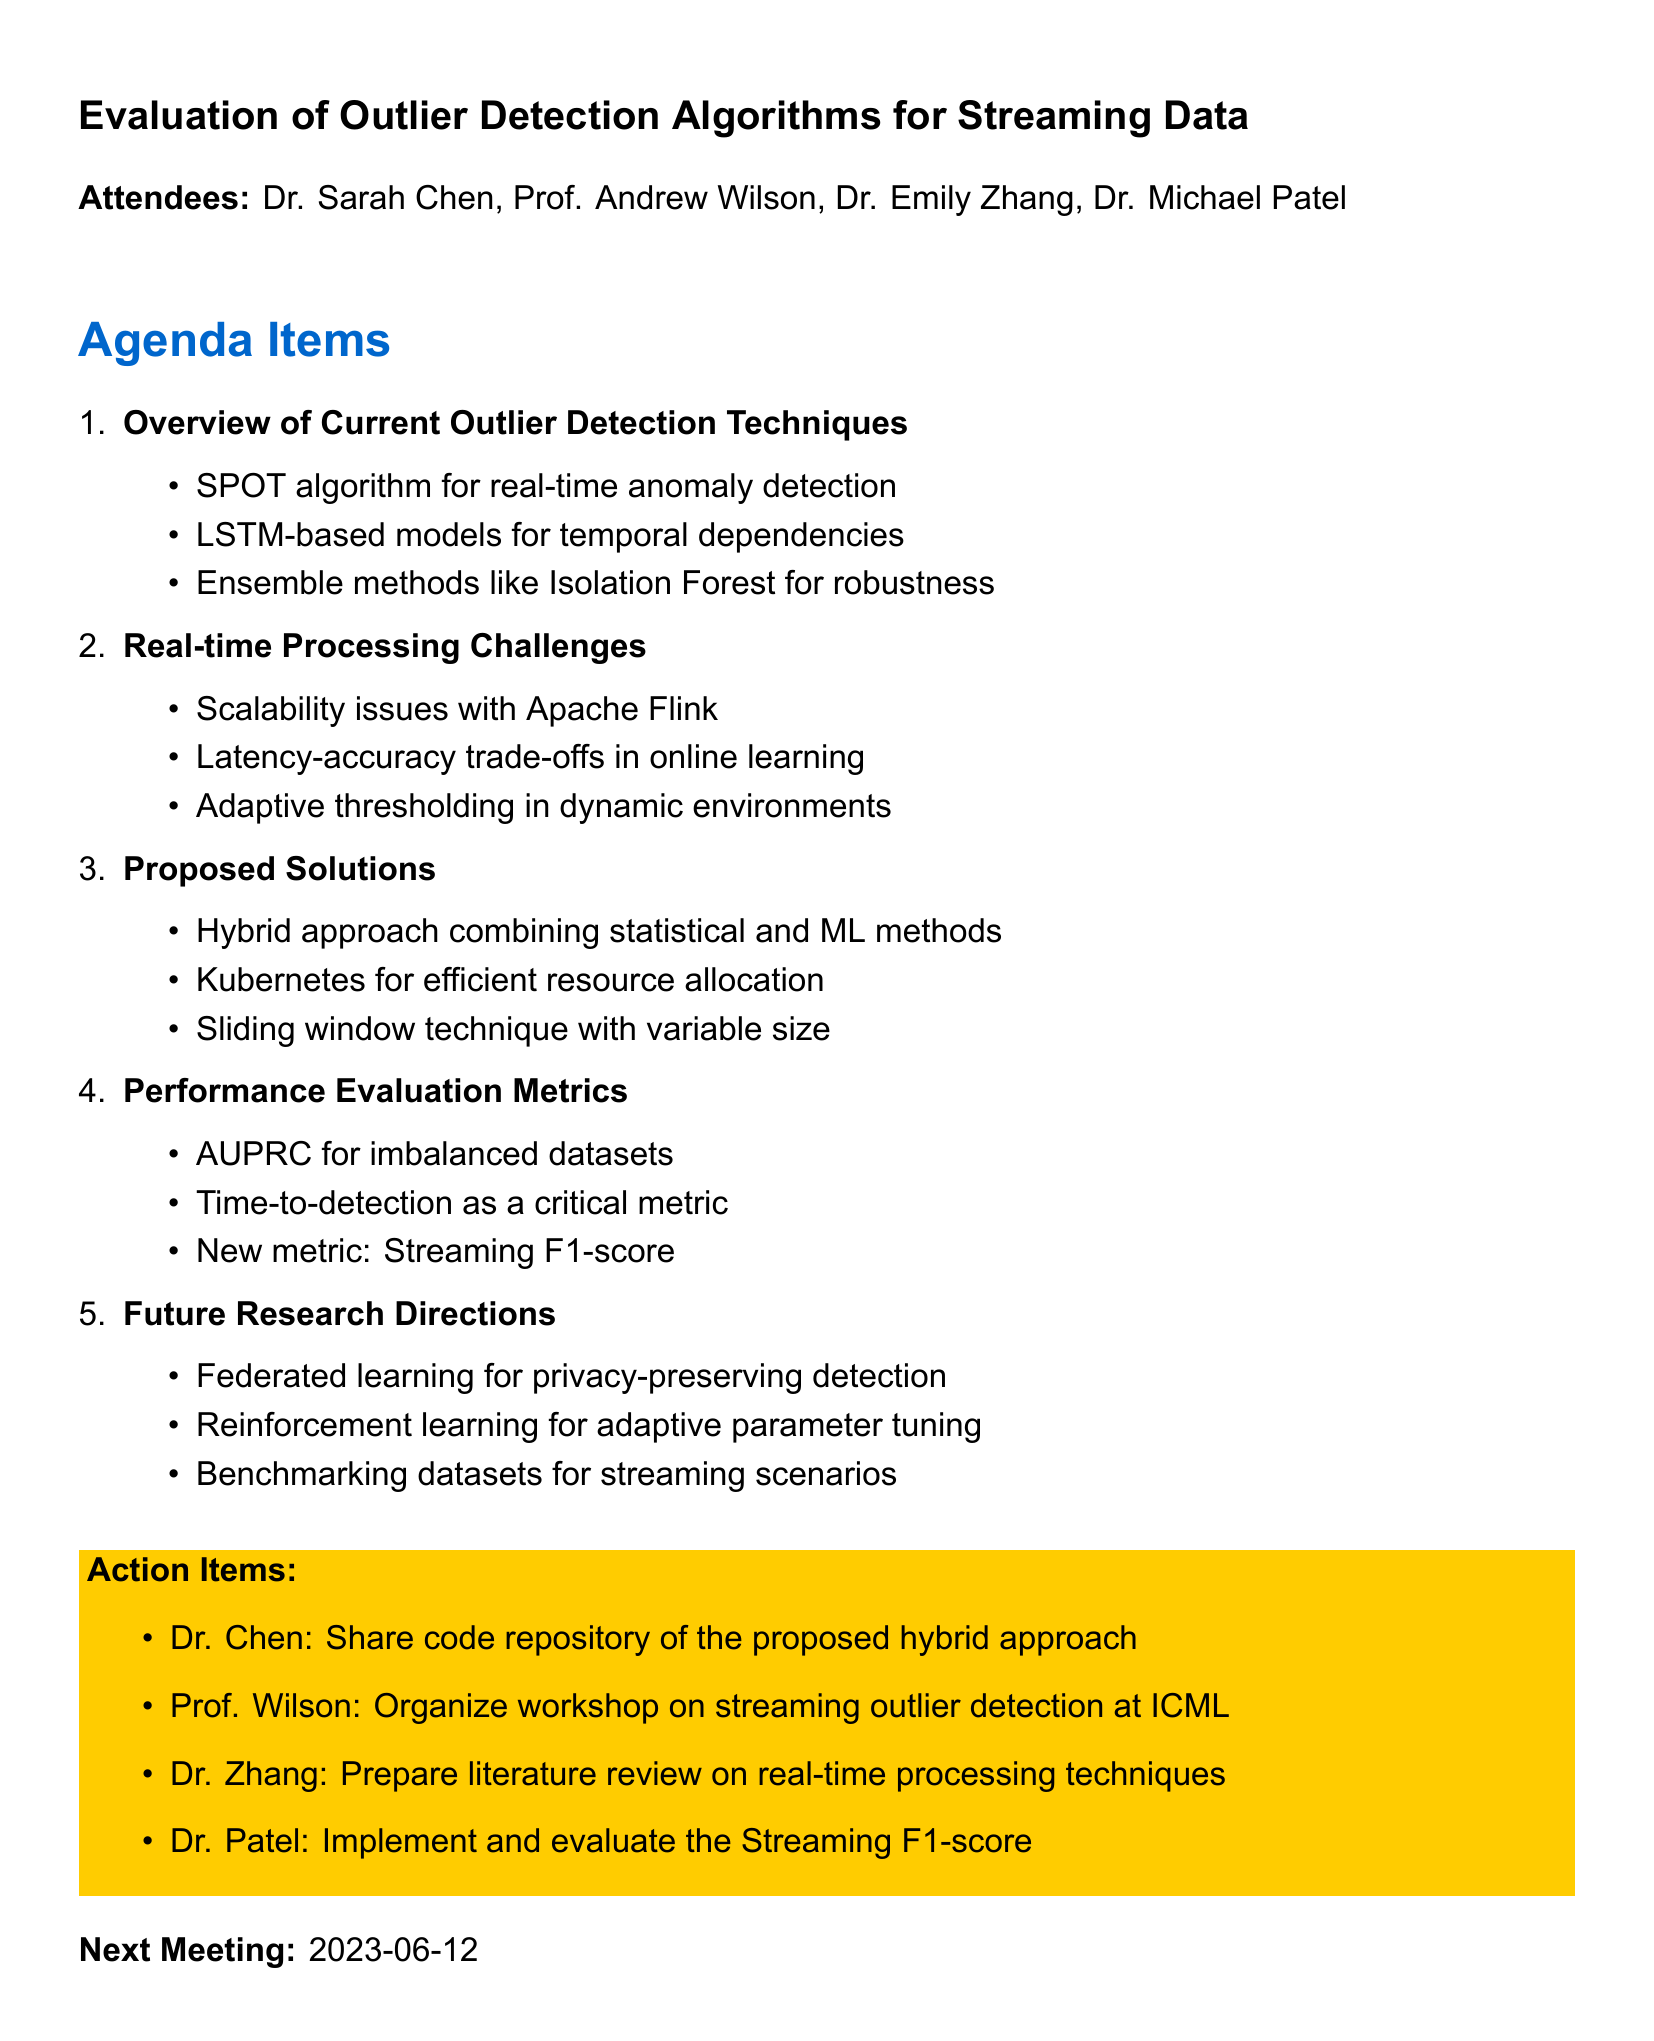What is the title of the meeting? The title of the meeting is provided at the beginning of the document.
Answer: Evaluation of Outlier Detection Algorithms for Streaming Data Who organized the workshop on streaming outlier detection? Prof. Wilson's action item mentions organizing a workshop, indicating he is responsible for it.
Answer: Prof. Wilson What is the date of the next meeting? The next meeting date is specifically mentioned towards the end of the document.
Answer: 2023-06-12 What algorithm was discussed for real-time anomaly detection? The first agenda item lists the SPOT algorithm as part of the current techniques discussed.
Answer: SPOT What new metric was proposed for evaluation? The discussion on performance evaluation metrics mentions a new metric that was proposed.
Answer: Streaming F1-score What are the scalability challenges mentioned? The second agenda item notes scalability issues, specifically in relation to data streams.
Answer: Apache Flink Which approach combines statistical and machine learning methods? The proposed solutions section introduces a hybrid approach, detailing its components.
Answer: Hybrid approach What is one research direction mentioned for privacy? The future research directions item pertains to federated learning related to privacy issues.
Answer: Federated learning 